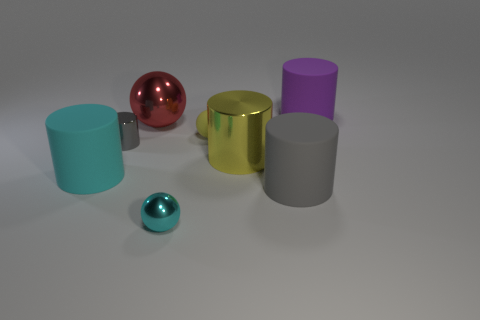Subtract all rubber balls. How many balls are left? 2 Add 1 tiny cyan shiny spheres. How many objects exist? 9 Subtract 3 spheres. How many spheres are left? 0 Subtract all cylinders. How many objects are left? 3 Subtract all cyan cylinders. How many cylinders are left? 4 Subtract all big green metallic blocks. Subtract all big shiny things. How many objects are left? 6 Add 2 large purple cylinders. How many large purple cylinders are left? 3 Add 8 big cyan objects. How many big cyan objects exist? 9 Subtract 0 blue cylinders. How many objects are left? 8 Subtract all blue cylinders. Subtract all red cubes. How many cylinders are left? 5 